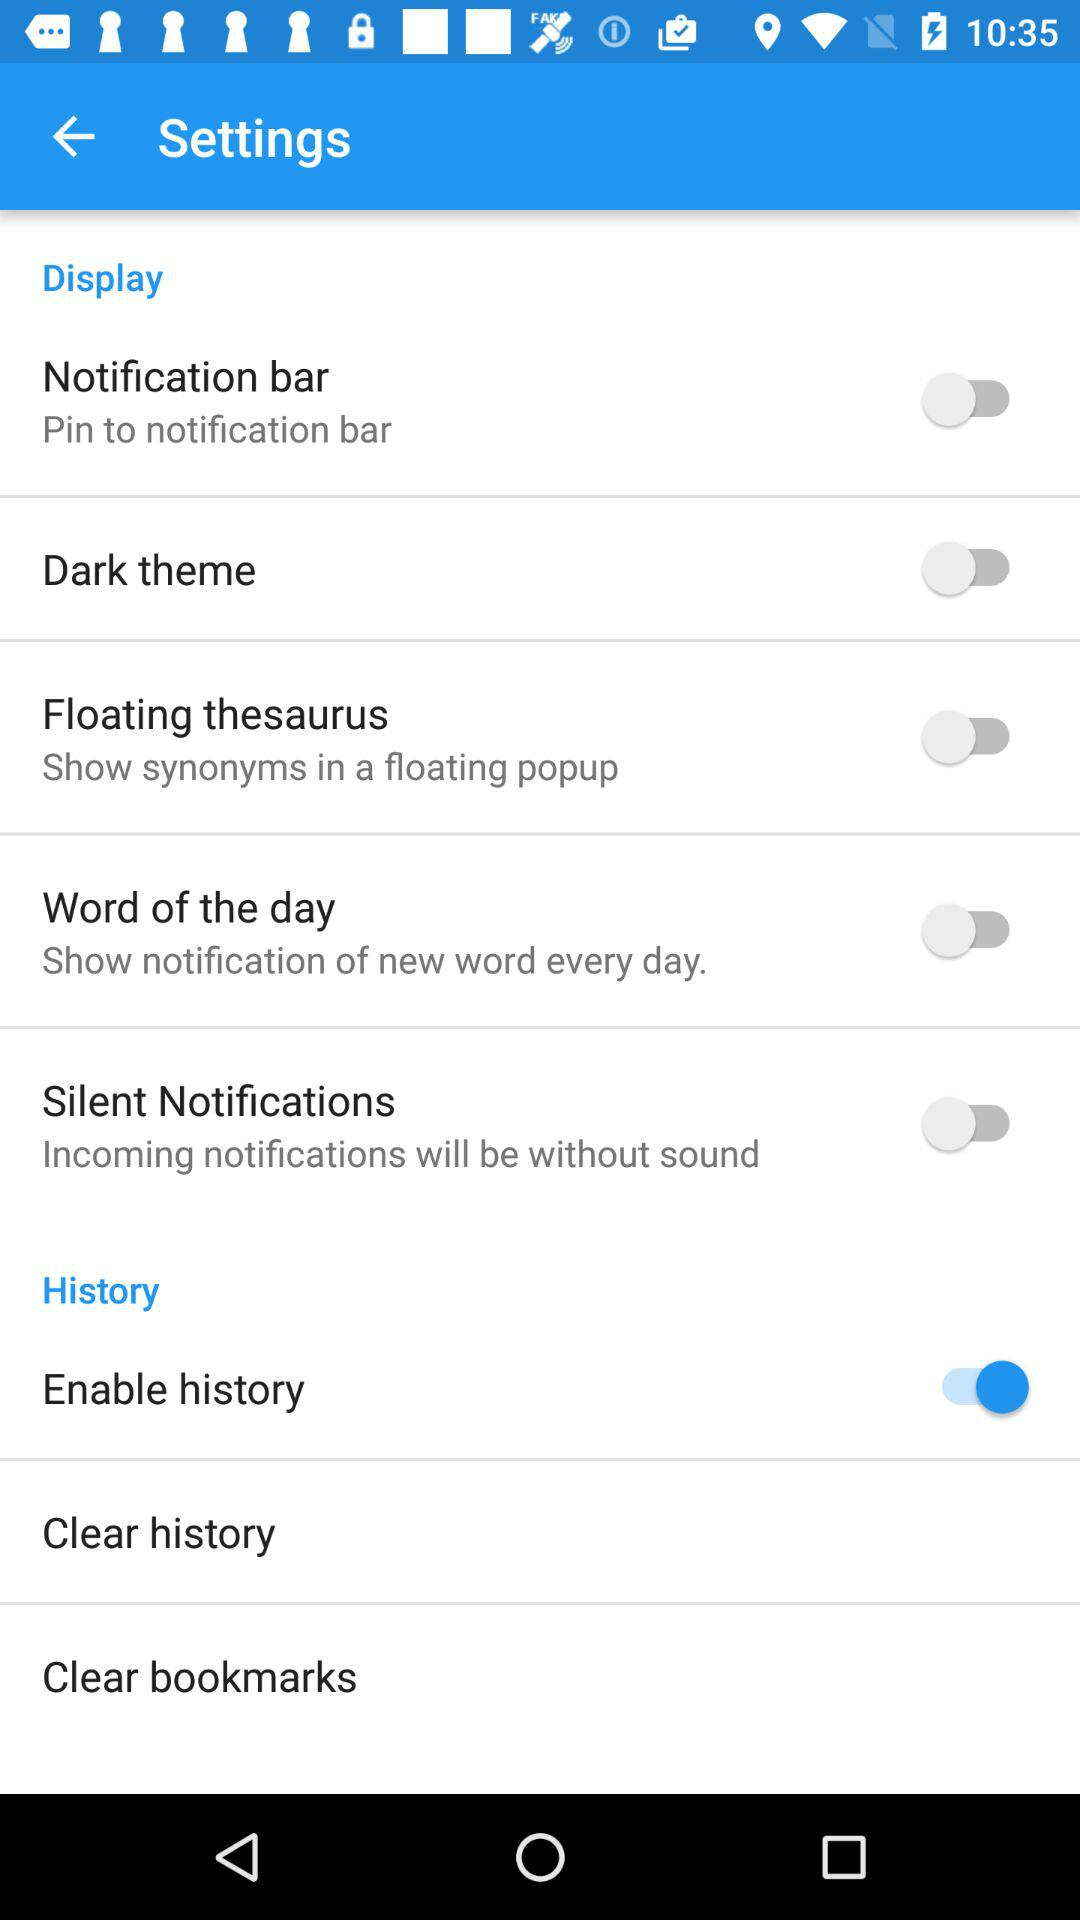How many items are under the History category?
Answer the question using a single word or phrase. 3 